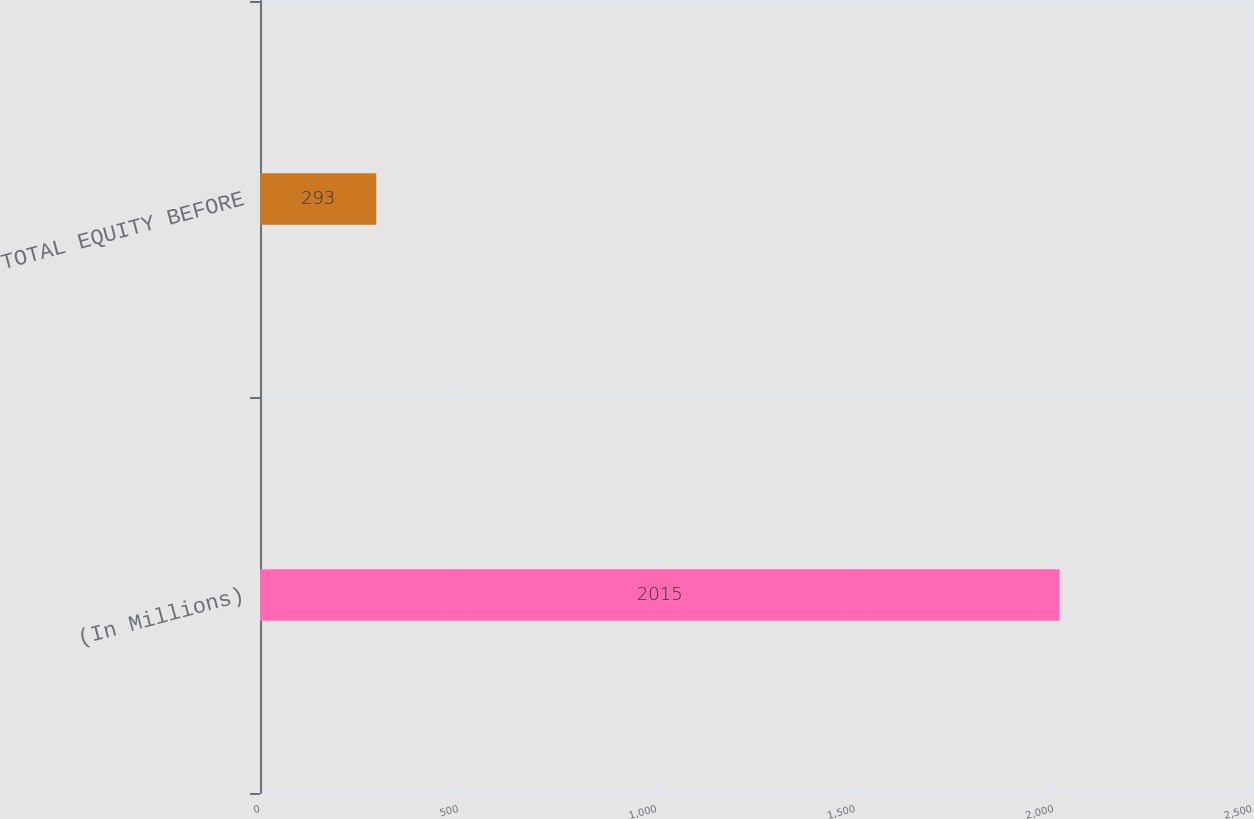<chart> <loc_0><loc_0><loc_500><loc_500><bar_chart><fcel>(In Millions)<fcel>TOTAL EQUITY BEFORE<nl><fcel>2015<fcel>293<nl></chart> 